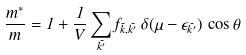<formula> <loc_0><loc_0><loc_500><loc_500>\frac { m ^ { * } } { m } = 1 + \frac { 1 } { V } \sum _ { \vec { k ^ { \prime } } } f _ { \vec { k } , \vec { k ^ { \prime } } } \, \delta ( \mu - \epsilon _ { \vec { k ^ { \prime } } } ) \, \cos \theta</formula> 